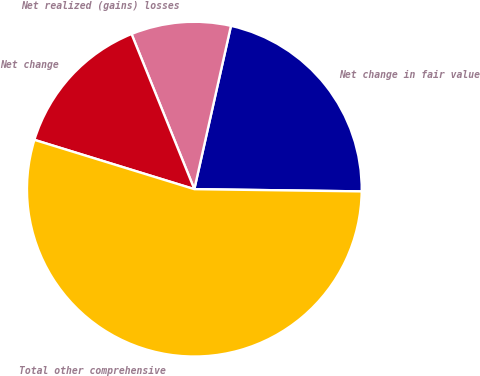Convert chart to OTSL. <chart><loc_0><loc_0><loc_500><loc_500><pie_chart><fcel>Net change in fair value<fcel>Net realized (gains) losses<fcel>Net change<fcel>Total other comprehensive<nl><fcel>21.7%<fcel>9.63%<fcel>14.12%<fcel>54.54%<nl></chart> 